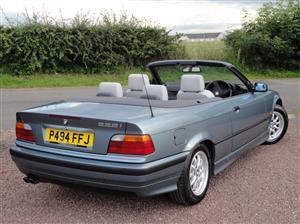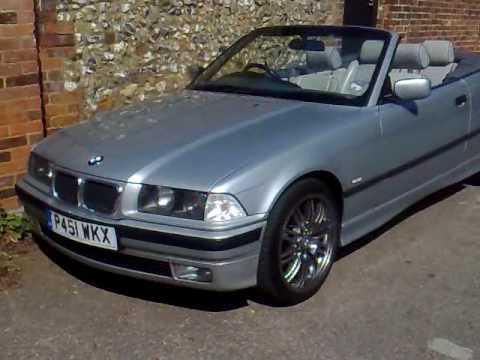The first image is the image on the left, the second image is the image on the right. Analyze the images presented: Is the assertion "The car in the right image is facing towards the right." valid? Answer yes or no. No. The first image is the image on the left, the second image is the image on the right. Considering the images on both sides, is "There are two cars, but only one roof." valid? Answer yes or no. No. 